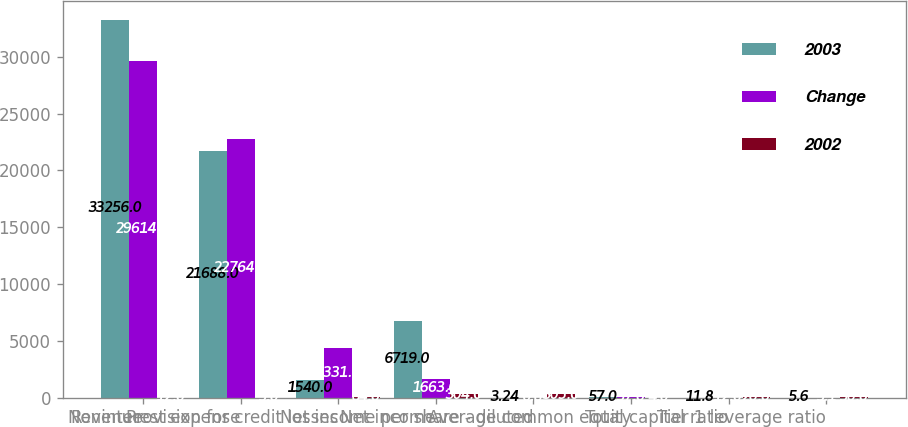Convert chart. <chart><loc_0><loc_0><loc_500><loc_500><stacked_bar_chart><ecel><fcel>Revenue<fcel>Noninterest expense<fcel>Provision for credit losses<fcel>Net income<fcel>Net income per share - diluted<fcel>Average common equity<fcel>Total capital ratio<fcel>Tier 1 leverage ratio<nl><fcel>2003<fcel>33256<fcel>21688<fcel>1540<fcel>6719<fcel>3.24<fcel>57<fcel>11.8<fcel>5.6<nl><fcel>Change<fcel>29614<fcel>22764<fcel>4331<fcel>1663<fcel>0.8<fcel>57<fcel>12<fcel>5.1<nl><fcel>2002<fcel>12<fcel>5<fcel>64<fcel>304<fcel>305<fcel>4<fcel>20<fcel>50<nl></chart> 